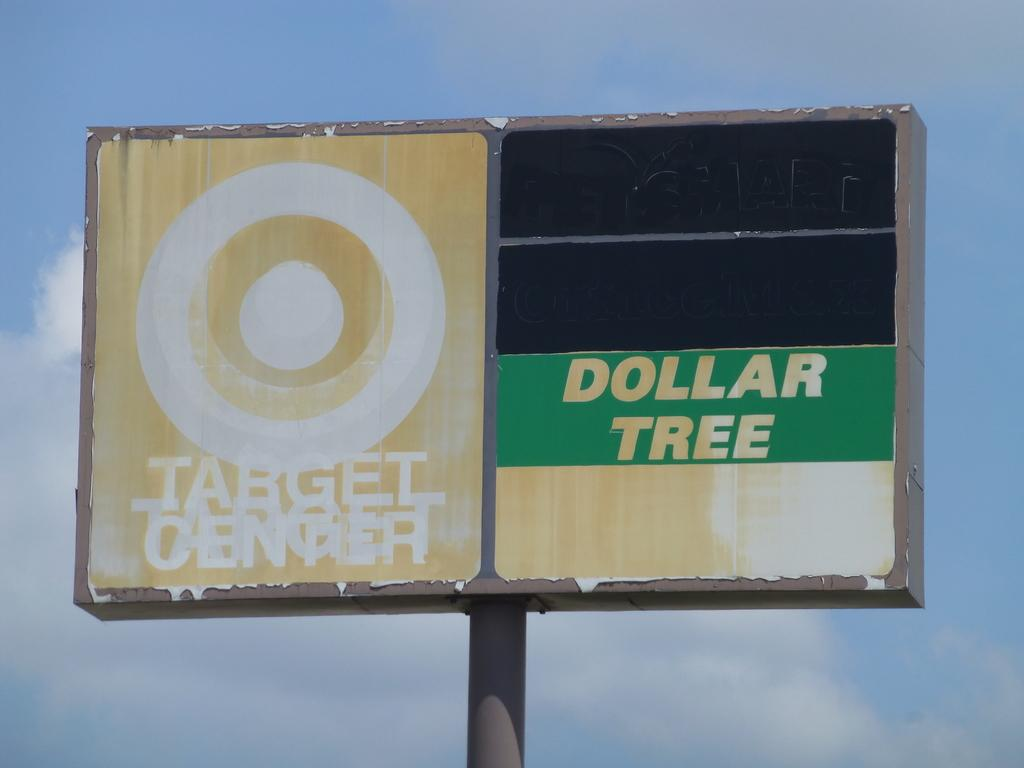<image>
Summarize the visual content of the image. An old battered billboard stands tall with signs for Target and the Dollar Tree 